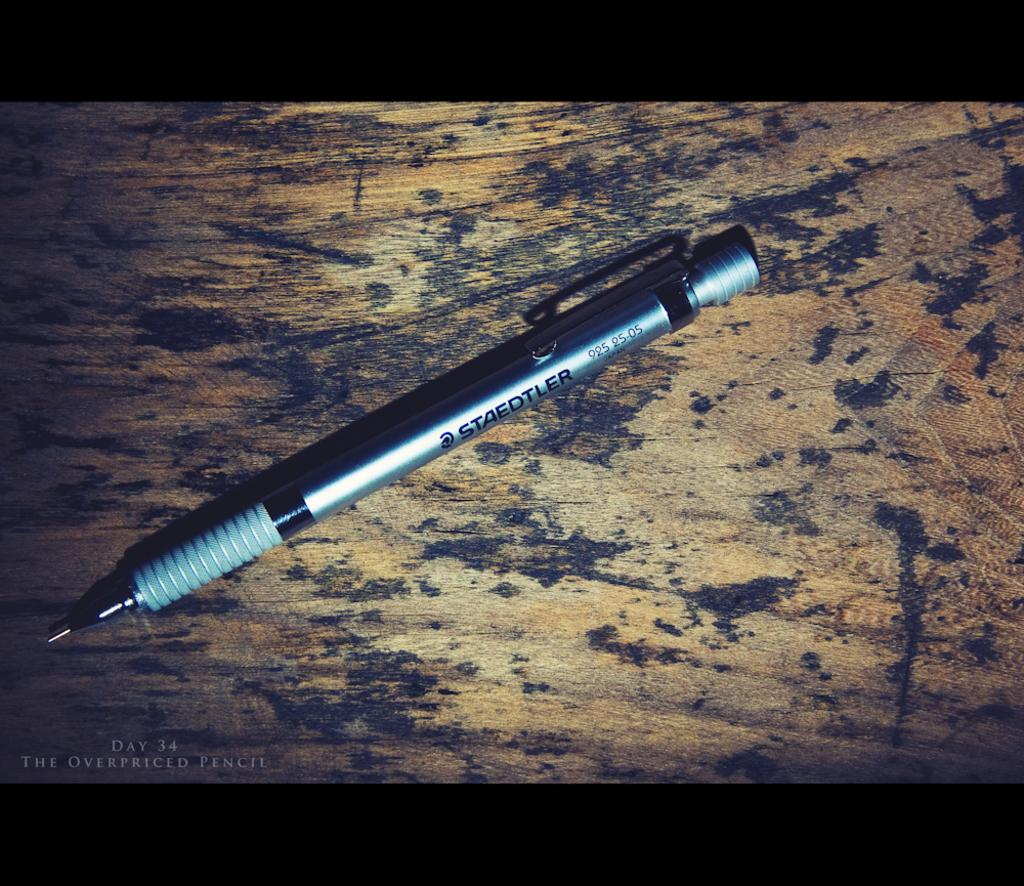What object is in the center of the image? There is a pen in the center of the image. Where is the pen located? The pen is on a table. How many babies are kicking the pen in the image? There are no babies or kicking actions present in the image; it only features a pen on a table. 